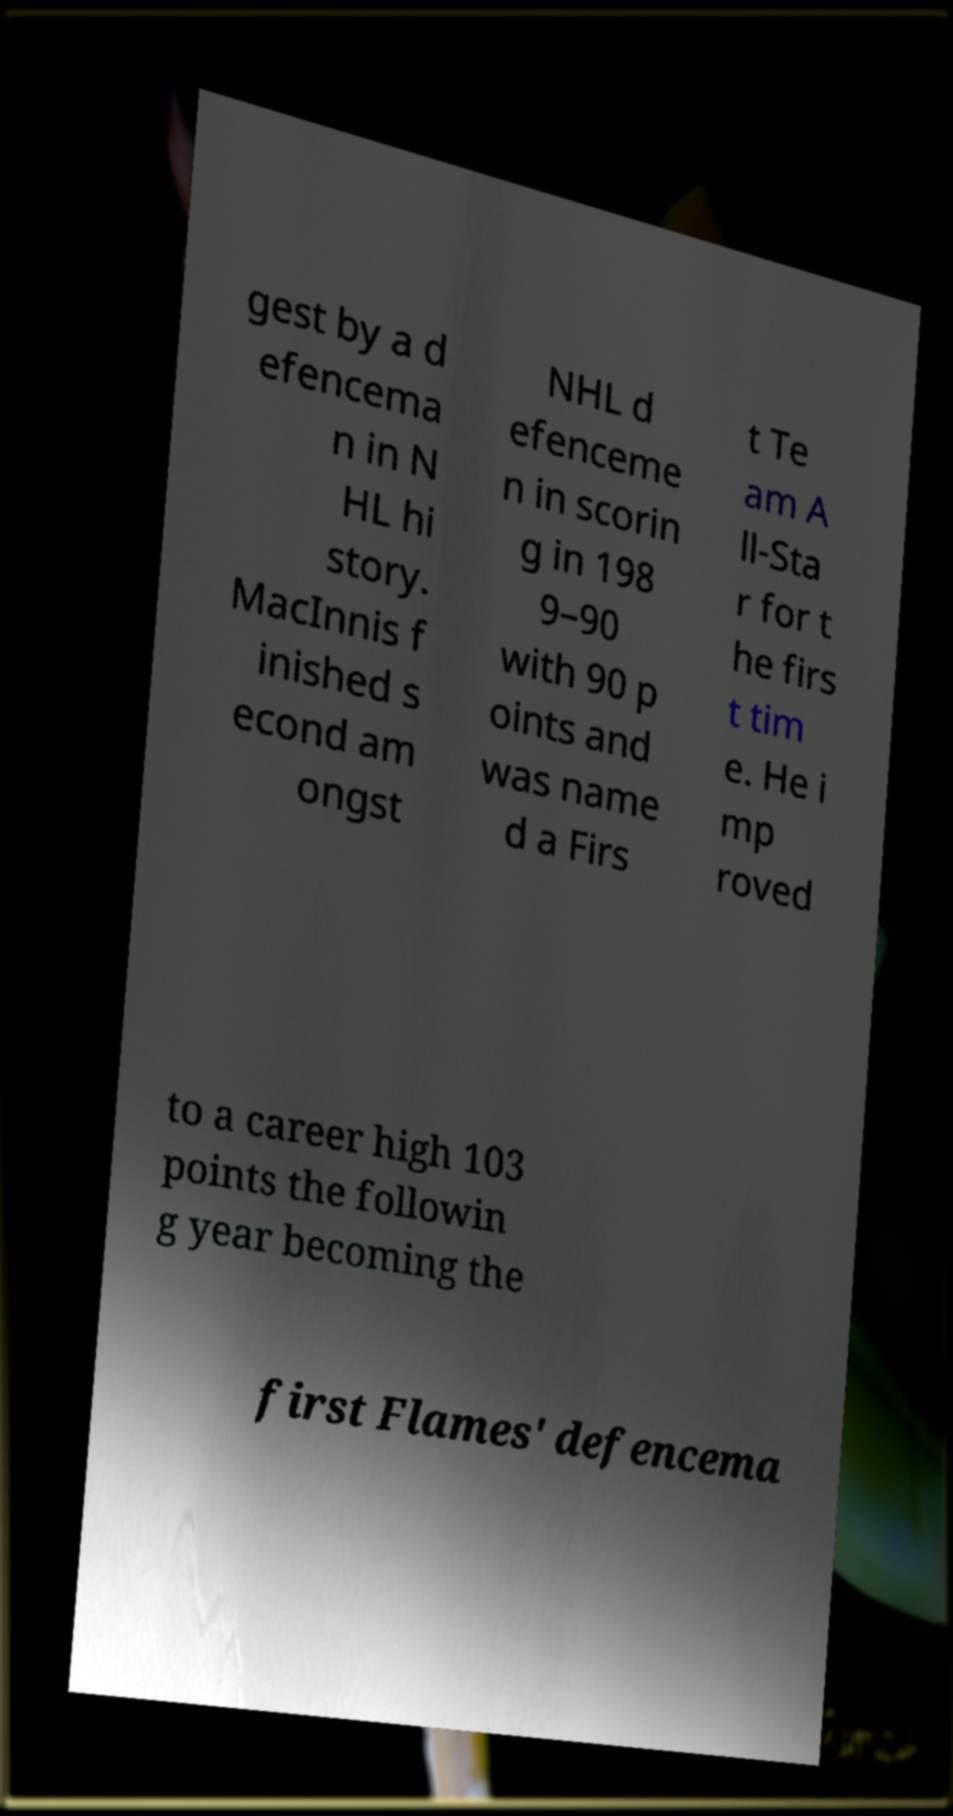There's text embedded in this image that I need extracted. Can you transcribe it verbatim? gest by a d efencema n in N HL hi story. MacInnis f inished s econd am ongst NHL d efenceme n in scorin g in 198 9–90 with 90 p oints and was name d a Firs t Te am A ll-Sta r for t he firs t tim e. He i mp roved to a career high 103 points the followin g year becoming the first Flames' defencema 